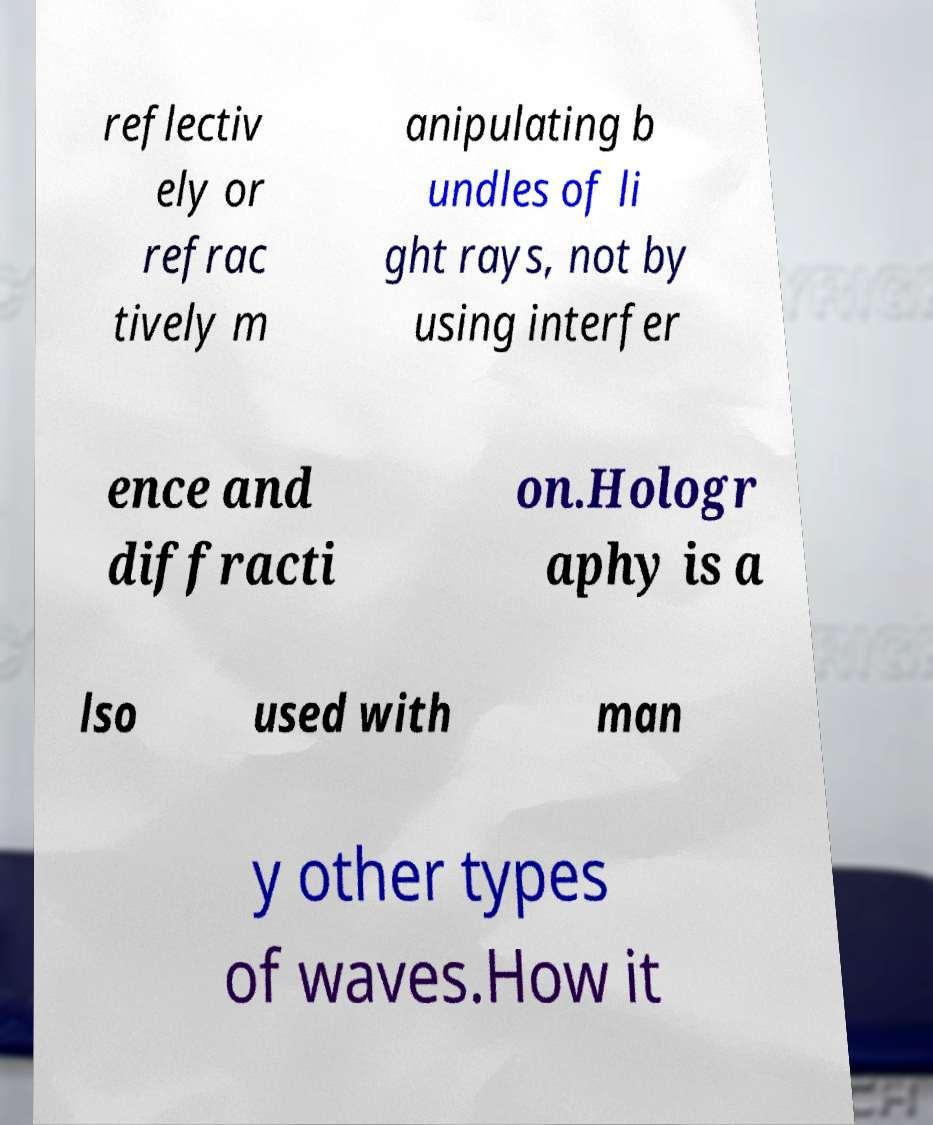I need the written content from this picture converted into text. Can you do that? reflectiv ely or refrac tively m anipulating b undles of li ght rays, not by using interfer ence and diffracti on.Hologr aphy is a lso used with man y other types of waves.How it 